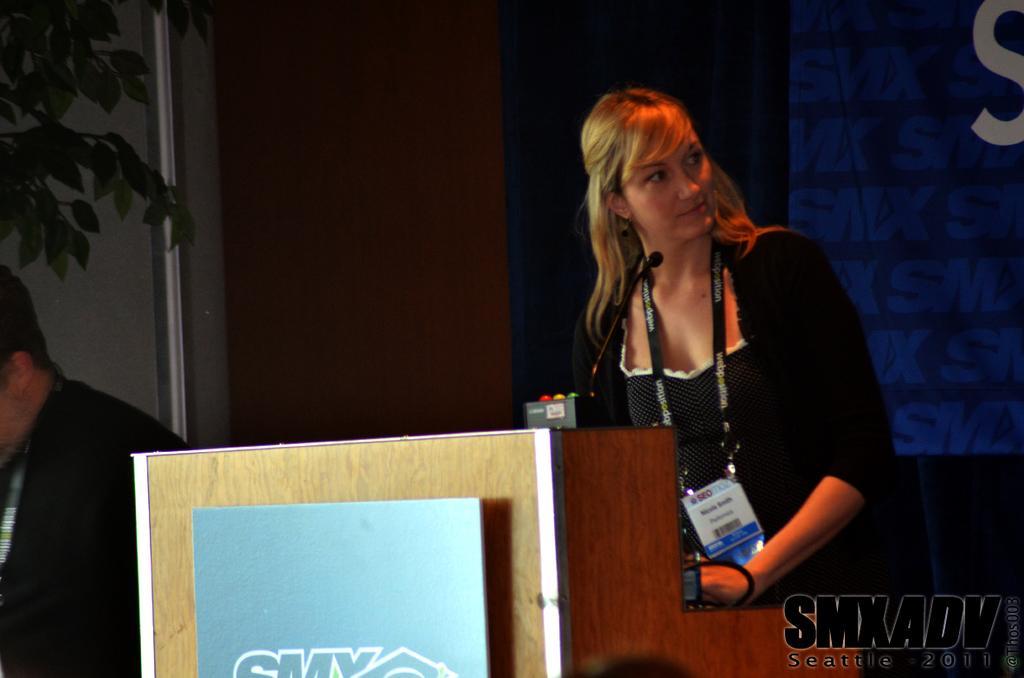Describe this image in one or two sentences. In this picture I can see there is a woman standing, there is a podium in front of her and there is a microphone in front of her. She is wearing an ID card and is looking at the right side. There is a man standing at left and there is a plant into left and there is a screen in the backdrop. 